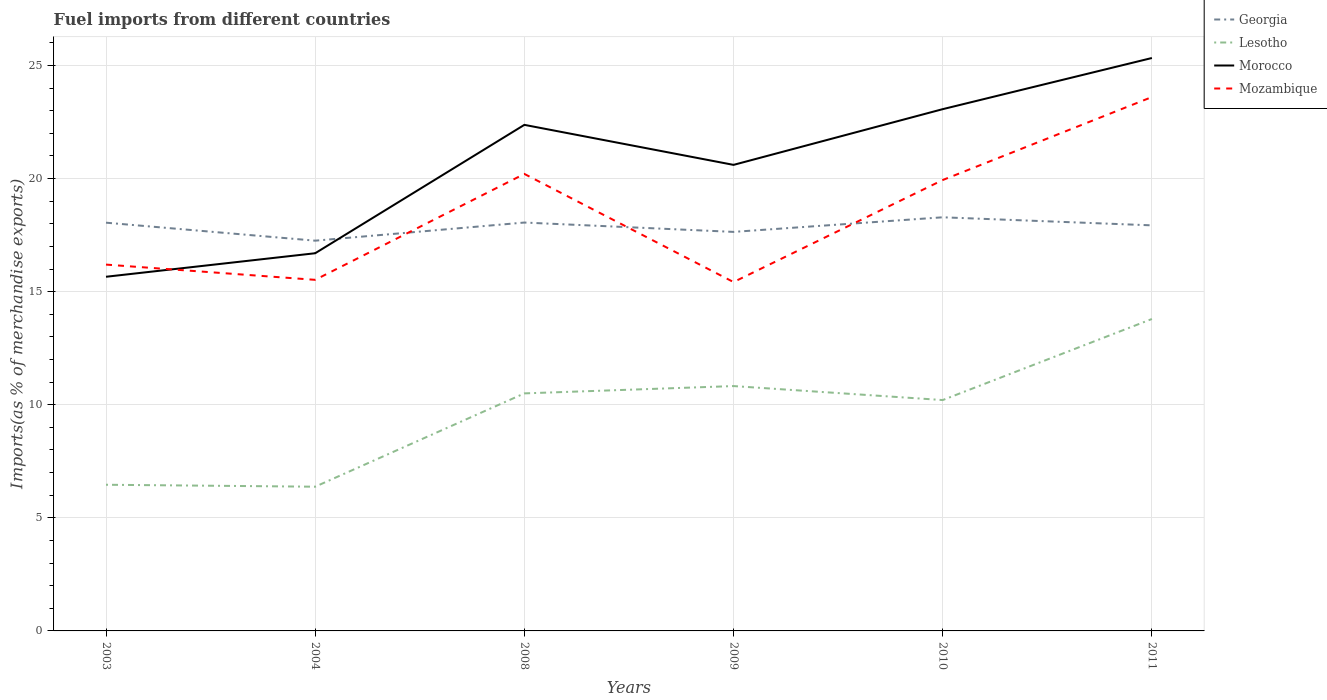Does the line corresponding to Morocco intersect with the line corresponding to Mozambique?
Keep it short and to the point. Yes. Is the number of lines equal to the number of legend labels?
Your answer should be compact. Yes. Across all years, what is the maximum percentage of imports to different countries in Georgia?
Make the answer very short. 17.25. What is the total percentage of imports to different countries in Mozambique in the graph?
Your response must be concise. 4.78. What is the difference between the highest and the second highest percentage of imports to different countries in Mozambique?
Keep it short and to the point. 8.18. What is the difference between the highest and the lowest percentage of imports to different countries in Mozambique?
Offer a terse response. 3. Is the percentage of imports to different countries in Mozambique strictly greater than the percentage of imports to different countries in Lesotho over the years?
Your response must be concise. No. What is the difference between two consecutive major ticks on the Y-axis?
Offer a very short reply. 5. Does the graph contain any zero values?
Keep it short and to the point. No. Does the graph contain grids?
Keep it short and to the point. Yes. How many legend labels are there?
Your response must be concise. 4. What is the title of the graph?
Provide a short and direct response. Fuel imports from different countries. Does "Mali" appear as one of the legend labels in the graph?
Give a very brief answer. No. What is the label or title of the X-axis?
Make the answer very short. Years. What is the label or title of the Y-axis?
Provide a short and direct response. Imports(as % of merchandise exports). What is the Imports(as % of merchandise exports) in Georgia in 2003?
Your answer should be compact. 18.05. What is the Imports(as % of merchandise exports) of Lesotho in 2003?
Offer a very short reply. 6.46. What is the Imports(as % of merchandise exports) in Morocco in 2003?
Your answer should be compact. 15.66. What is the Imports(as % of merchandise exports) of Mozambique in 2003?
Keep it short and to the point. 16.2. What is the Imports(as % of merchandise exports) of Georgia in 2004?
Ensure brevity in your answer.  17.25. What is the Imports(as % of merchandise exports) in Lesotho in 2004?
Your answer should be very brief. 6.38. What is the Imports(as % of merchandise exports) in Morocco in 2004?
Your answer should be compact. 16.7. What is the Imports(as % of merchandise exports) of Mozambique in 2004?
Your answer should be very brief. 15.52. What is the Imports(as % of merchandise exports) in Georgia in 2008?
Your response must be concise. 18.06. What is the Imports(as % of merchandise exports) of Lesotho in 2008?
Your response must be concise. 10.5. What is the Imports(as % of merchandise exports) of Morocco in 2008?
Give a very brief answer. 22.37. What is the Imports(as % of merchandise exports) in Mozambique in 2008?
Offer a terse response. 20.2. What is the Imports(as % of merchandise exports) in Georgia in 2009?
Offer a terse response. 17.64. What is the Imports(as % of merchandise exports) of Lesotho in 2009?
Give a very brief answer. 10.83. What is the Imports(as % of merchandise exports) in Morocco in 2009?
Your answer should be very brief. 20.61. What is the Imports(as % of merchandise exports) in Mozambique in 2009?
Keep it short and to the point. 15.42. What is the Imports(as % of merchandise exports) in Georgia in 2010?
Provide a succinct answer. 18.29. What is the Imports(as % of merchandise exports) in Lesotho in 2010?
Give a very brief answer. 10.21. What is the Imports(as % of merchandise exports) in Morocco in 2010?
Your answer should be compact. 23.07. What is the Imports(as % of merchandise exports) in Mozambique in 2010?
Provide a succinct answer. 19.94. What is the Imports(as % of merchandise exports) in Georgia in 2011?
Your answer should be very brief. 17.93. What is the Imports(as % of merchandise exports) of Lesotho in 2011?
Offer a very short reply. 13.79. What is the Imports(as % of merchandise exports) in Morocco in 2011?
Provide a short and direct response. 25.33. What is the Imports(as % of merchandise exports) of Mozambique in 2011?
Ensure brevity in your answer.  23.6. Across all years, what is the maximum Imports(as % of merchandise exports) of Georgia?
Your answer should be very brief. 18.29. Across all years, what is the maximum Imports(as % of merchandise exports) in Lesotho?
Your answer should be very brief. 13.79. Across all years, what is the maximum Imports(as % of merchandise exports) in Morocco?
Offer a terse response. 25.33. Across all years, what is the maximum Imports(as % of merchandise exports) in Mozambique?
Your answer should be very brief. 23.6. Across all years, what is the minimum Imports(as % of merchandise exports) in Georgia?
Offer a terse response. 17.25. Across all years, what is the minimum Imports(as % of merchandise exports) of Lesotho?
Ensure brevity in your answer.  6.38. Across all years, what is the minimum Imports(as % of merchandise exports) of Morocco?
Ensure brevity in your answer.  15.66. Across all years, what is the minimum Imports(as % of merchandise exports) in Mozambique?
Give a very brief answer. 15.42. What is the total Imports(as % of merchandise exports) in Georgia in the graph?
Give a very brief answer. 107.22. What is the total Imports(as % of merchandise exports) in Lesotho in the graph?
Make the answer very short. 58.16. What is the total Imports(as % of merchandise exports) of Morocco in the graph?
Ensure brevity in your answer.  123.74. What is the total Imports(as % of merchandise exports) in Mozambique in the graph?
Your response must be concise. 110.89. What is the difference between the Imports(as % of merchandise exports) in Georgia in 2003 and that in 2004?
Give a very brief answer. 0.8. What is the difference between the Imports(as % of merchandise exports) in Lesotho in 2003 and that in 2004?
Provide a short and direct response. 0.09. What is the difference between the Imports(as % of merchandise exports) in Morocco in 2003 and that in 2004?
Make the answer very short. -1.04. What is the difference between the Imports(as % of merchandise exports) of Mozambique in 2003 and that in 2004?
Your answer should be very brief. 0.67. What is the difference between the Imports(as % of merchandise exports) of Georgia in 2003 and that in 2008?
Keep it short and to the point. -0.01. What is the difference between the Imports(as % of merchandise exports) of Lesotho in 2003 and that in 2008?
Give a very brief answer. -4.04. What is the difference between the Imports(as % of merchandise exports) of Morocco in 2003 and that in 2008?
Offer a very short reply. -6.72. What is the difference between the Imports(as % of merchandise exports) in Mozambique in 2003 and that in 2008?
Make the answer very short. -4.01. What is the difference between the Imports(as % of merchandise exports) of Georgia in 2003 and that in 2009?
Provide a succinct answer. 0.41. What is the difference between the Imports(as % of merchandise exports) in Lesotho in 2003 and that in 2009?
Your answer should be very brief. -4.36. What is the difference between the Imports(as % of merchandise exports) of Morocco in 2003 and that in 2009?
Provide a short and direct response. -4.95. What is the difference between the Imports(as % of merchandise exports) in Mozambique in 2003 and that in 2009?
Provide a succinct answer. 0.77. What is the difference between the Imports(as % of merchandise exports) of Georgia in 2003 and that in 2010?
Keep it short and to the point. -0.24. What is the difference between the Imports(as % of merchandise exports) in Lesotho in 2003 and that in 2010?
Keep it short and to the point. -3.74. What is the difference between the Imports(as % of merchandise exports) in Morocco in 2003 and that in 2010?
Give a very brief answer. -7.41. What is the difference between the Imports(as % of merchandise exports) of Mozambique in 2003 and that in 2010?
Make the answer very short. -3.74. What is the difference between the Imports(as % of merchandise exports) in Georgia in 2003 and that in 2011?
Ensure brevity in your answer.  0.12. What is the difference between the Imports(as % of merchandise exports) in Lesotho in 2003 and that in 2011?
Offer a terse response. -7.33. What is the difference between the Imports(as % of merchandise exports) of Morocco in 2003 and that in 2011?
Ensure brevity in your answer.  -9.67. What is the difference between the Imports(as % of merchandise exports) of Mozambique in 2003 and that in 2011?
Provide a succinct answer. -7.41. What is the difference between the Imports(as % of merchandise exports) of Georgia in 2004 and that in 2008?
Provide a short and direct response. -0.8. What is the difference between the Imports(as % of merchandise exports) in Lesotho in 2004 and that in 2008?
Provide a short and direct response. -4.13. What is the difference between the Imports(as % of merchandise exports) in Morocco in 2004 and that in 2008?
Your answer should be very brief. -5.68. What is the difference between the Imports(as % of merchandise exports) of Mozambique in 2004 and that in 2008?
Offer a very short reply. -4.68. What is the difference between the Imports(as % of merchandise exports) in Georgia in 2004 and that in 2009?
Provide a short and direct response. -0.39. What is the difference between the Imports(as % of merchandise exports) in Lesotho in 2004 and that in 2009?
Keep it short and to the point. -4.45. What is the difference between the Imports(as % of merchandise exports) in Morocco in 2004 and that in 2009?
Offer a terse response. -3.91. What is the difference between the Imports(as % of merchandise exports) in Mozambique in 2004 and that in 2009?
Offer a very short reply. 0.1. What is the difference between the Imports(as % of merchandise exports) of Georgia in 2004 and that in 2010?
Provide a short and direct response. -1.03. What is the difference between the Imports(as % of merchandise exports) of Lesotho in 2004 and that in 2010?
Keep it short and to the point. -3.83. What is the difference between the Imports(as % of merchandise exports) in Morocco in 2004 and that in 2010?
Your answer should be very brief. -6.37. What is the difference between the Imports(as % of merchandise exports) in Mozambique in 2004 and that in 2010?
Give a very brief answer. -4.41. What is the difference between the Imports(as % of merchandise exports) in Georgia in 2004 and that in 2011?
Make the answer very short. -0.68. What is the difference between the Imports(as % of merchandise exports) in Lesotho in 2004 and that in 2011?
Provide a succinct answer. -7.41. What is the difference between the Imports(as % of merchandise exports) in Morocco in 2004 and that in 2011?
Offer a very short reply. -8.63. What is the difference between the Imports(as % of merchandise exports) of Mozambique in 2004 and that in 2011?
Keep it short and to the point. -8.08. What is the difference between the Imports(as % of merchandise exports) in Georgia in 2008 and that in 2009?
Ensure brevity in your answer.  0.41. What is the difference between the Imports(as % of merchandise exports) in Lesotho in 2008 and that in 2009?
Your answer should be very brief. -0.32. What is the difference between the Imports(as % of merchandise exports) in Morocco in 2008 and that in 2009?
Your answer should be compact. 1.77. What is the difference between the Imports(as % of merchandise exports) of Mozambique in 2008 and that in 2009?
Make the answer very short. 4.78. What is the difference between the Imports(as % of merchandise exports) of Georgia in 2008 and that in 2010?
Keep it short and to the point. -0.23. What is the difference between the Imports(as % of merchandise exports) in Lesotho in 2008 and that in 2010?
Keep it short and to the point. 0.29. What is the difference between the Imports(as % of merchandise exports) of Morocco in 2008 and that in 2010?
Your answer should be compact. -0.69. What is the difference between the Imports(as % of merchandise exports) in Mozambique in 2008 and that in 2010?
Offer a very short reply. 0.27. What is the difference between the Imports(as % of merchandise exports) of Georgia in 2008 and that in 2011?
Your answer should be very brief. 0.12. What is the difference between the Imports(as % of merchandise exports) in Lesotho in 2008 and that in 2011?
Offer a very short reply. -3.29. What is the difference between the Imports(as % of merchandise exports) of Morocco in 2008 and that in 2011?
Offer a terse response. -2.96. What is the difference between the Imports(as % of merchandise exports) in Mozambique in 2008 and that in 2011?
Your response must be concise. -3.4. What is the difference between the Imports(as % of merchandise exports) of Georgia in 2009 and that in 2010?
Ensure brevity in your answer.  -0.65. What is the difference between the Imports(as % of merchandise exports) of Lesotho in 2009 and that in 2010?
Keep it short and to the point. 0.62. What is the difference between the Imports(as % of merchandise exports) of Morocco in 2009 and that in 2010?
Provide a succinct answer. -2.46. What is the difference between the Imports(as % of merchandise exports) of Mozambique in 2009 and that in 2010?
Offer a very short reply. -4.51. What is the difference between the Imports(as % of merchandise exports) in Georgia in 2009 and that in 2011?
Your response must be concise. -0.29. What is the difference between the Imports(as % of merchandise exports) of Lesotho in 2009 and that in 2011?
Ensure brevity in your answer.  -2.97. What is the difference between the Imports(as % of merchandise exports) of Morocco in 2009 and that in 2011?
Provide a short and direct response. -4.72. What is the difference between the Imports(as % of merchandise exports) of Mozambique in 2009 and that in 2011?
Provide a short and direct response. -8.18. What is the difference between the Imports(as % of merchandise exports) of Georgia in 2010 and that in 2011?
Offer a terse response. 0.36. What is the difference between the Imports(as % of merchandise exports) of Lesotho in 2010 and that in 2011?
Provide a short and direct response. -3.58. What is the difference between the Imports(as % of merchandise exports) in Morocco in 2010 and that in 2011?
Provide a succinct answer. -2.26. What is the difference between the Imports(as % of merchandise exports) of Mozambique in 2010 and that in 2011?
Give a very brief answer. -3.67. What is the difference between the Imports(as % of merchandise exports) in Georgia in 2003 and the Imports(as % of merchandise exports) in Lesotho in 2004?
Make the answer very short. 11.67. What is the difference between the Imports(as % of merchandise exports) of Georgia in 2003 and the Imports(as % of merchandise exports) of Morocco in 2004?
Your answer should be very brief. 1.35. What is the difference between the Imports(as % of merchandise exports) of Georgia in 2003 and the Imports(as % of merchandise exports) of Mozambique in 2004?
Make the answer very short. 2.53. What is the difference between the Imports(as % of merchandise exports) of Lesotho in 2003 and the Imports(as % of merchandise exports) of Morocco in 2004?
Provide a succinct answer. -10.24. What is the difference between the Imports(as % of merchandise exports) of Lesotho in 2003 and the Imports(as % of merchandise exports) of Mozambique in 2004?
Your answer should be very brief. -9.06. What is the difference between the Imports(as % of merchandise exports) in Morocco in 2003 and the Imports(as % of merchandise exports) in Mozambique in 2004?
Keep it short and to the point. 0.14. What is the difference between the Imports(as % of merchandise exports) in Georgia in 2003 and the Imports(as % of merchandise exports) in Lesotho in 2008?
Offer a very short reply. 7.55. What is the difference between the Imports(as % of merchandise exports) in Georgia in 2003 and the Imports(as % of merchandise exports) in Morocco in 2008?
Ensure brevity in your answer.  -4.33. What is the difference between the Imports(as % of merchandise exports) in Georgia in 2003 and the Imports(as % of merchandise exports) in Mozambique in 2008?
Give a very brief answer. -2.16. What is the difference between the Imports(as % of merchandise exports) of Lesotho in 2003 and the Imports(as % of merchandise exports) of Morocco in 2008?
Offer a terse response. -15.91. What is the difference between the Imports(as % of merchandise exports) of Lesotho in 2003 and the Imports(as % of merchandise exports) of Mozambique in 2008?
Give a very brief answer. -13.74. What is the difference between the Imports(as % of merchandise exports) in Morocco in 2003 and the Imports(as % of merchandise exports) in Mozambique in 2008?
Make the answer very short. -4.55. What is the difference between the Imports(as % of merchandise exports) in Georgia in 2003 and the Imports(as % of merchandise exports) in Lesotho in 2009?
Offer a very short reply. 7.22. What is the difference between the Imports(as % of merchandise exports) in Georgia in 2003 and the Imports(as % of merchandise exports) in Morocco in 2009?
Provide a succinct answer. -2.56. What is the difference between the Imports(as % of merchandise exports) in Georgia in 2003 and the Imports(as % of merchandise exports) in Mozambique in 2009?
Make the answer very short. 2.63. What is the difference between the Imports(as % of merchandise exports) of Lesotho in 2003 and the Imports(as % of merchandise exports) of Morocco in 2009?
Your answer should be very brief. -14.14. What is the difference between the Imports(as % of merchandise exports) in Lesotho in 2003 and the Imports(as % of merchandise exports) in Mozambique in 2009?
Give a very brief answer. -8.96. What is the difference between the Imports(as % of merchandise exports) in Morocco in 2003 and the Imports(as % of merchandise exports) in Mozambique in 2009?
Offer a very short reply. 0.23. What is the difference between the Imports(as % of merchandise exports) in Georgia in 2003 and the Imports(as % of merchandise exports) in Lesotho in 2010?
Your answer should be compact. 7.84. What is the difference between the Imports(as % of merchandise exports) in Georgia in 2003 and the Imports(as % of merchandise exports) in Morocco in 2010?
Provide a short and direct response. -5.02. What is the difference between the Imports(as % of merchandise exports) of Georgia in 2003 and the Imports(as % of merchandise exports) of Mozambique in 2010?
Your response must be concise. -1.89. What is the difference between the Imports(as % of merchandise exports) in Lesotho in 2003 and the Imports(as % of merchandise exports) in Morocco in 2010?
Make the answer very short. -16.61. What is the difference between the Imports(as % of merchandise exports) of Lesotho in 2003 and the Imports(as % of merchandise exports) of Mozambique in 2010?
Offer a very short reply. -13.47. What is the difference between the Imports(as % of merchandise exports) in Morocco in 2003 and the Imports(as % of merchandise exports) in Mozambique in 2010?
Keep it short and to the point. -4.28. What is the difference between the Imports(as % of merchandise exports) of Georgia in 2003 and the Imports(as % of merchandise exports) of Lesotho in 2011?
Make the answer very short. 4.26. What is the difference between the Imports(as % of merchandise exports) in Georgia in 2003 and the Imports(as % of merchandise exports) in Morocco in 2011?
Offer a terse response. -7.28. What is the difference between the Imports(as % of merchandise exports) of Georgia in 2003 and the Imports(as % of merchandise exports) of Mozambique in 2011?
Keep it short and to the point. -5.55. What is the difference between the Imports(as % of merchandise exports) in Lesotho in 2003 and the Imports(as % of merchandise exports) in Morocco in 2011?
Provide a short and direct response. -18.87. What is the difference between the Imports(as % of merchandise exports) in Lesotho in 2003 and the Imports(as % of merchandise exports) in Mozambique in 2011?
Provide a succinct answer. -17.14. What is the difference between the Imports(as % of merchandise exports) of Morocco in 2003 and the Imports(as % of merchandise exports) of Mozambique in 2011?
Offer a terse response. -7.95. What is the difference between the Imports(as % of merchandise exports) in Georgia in 2004 and the Imports(as % of merchandise exports) in Lesotho in 2008?
Offer a terse response. 6.75. What is the difference between the Imports(as % of merchandise exports) in Georgia in 2004 and the Imports(as % of merchandise exports) in Morocco in 2008?
Your response must be concise. -5.12. What is the difference between the Imports(as % of merchandise exports) of Georgia in 2004 and the Imports(as % of merchandise exports) of Mozambique in 2008?
Your answer should be compact. -2.95. What is the difference between the Imports(as % of merchandise exports) in Lesotho in 2004 and the Imports(as % of merchandise exports) in Morocco in 2008?
Make the answer very short. -16. What is the difference between the Imports(as % of merchandise exports) in Lesotho in 2004 and the Imports(as % of merchandise exports) in Mozambique in 2008?
Make the answer very short. -13.83. What is the difference between the Imports(as % of merchandise exports) of Morocco in 2004 and the Imports(as % of merchandise exports) of Mozambique in 2008?
Give a very brief answer. -3.51. What is the difference between the Imports(as % of merchandise exports) in Georgia in 2004 and the Imports(as % of merchandise exports) in Lesotho in 2009?
Offer a terse response. 6.43. What is the difference between the Imports(as % of merchandise exports) in Georgia in 2004 and the Imports(as % of merchandise exports) in Morocco in 2009?
Your answer should be compact. -3.35. What is the difference between the Imports(as % of merchandise exports) of Georgia in 2004 and the Imports(as % of merchandise exports) of Mozambique in 2009?
Keep it short and to the point. 1.83. What is the difference between the Imports(as % of merchandise exports) of Lesotho in 2004 and the Imports(as % of merchandise exports) of Morocco in 2009?
Keep it short and to the point. -14.23. What is the difference between the Imports(as % of merchandise exports) in Lesotho in 2004 and the Imports(as % of merchandise exports) in Mozambique in 2009?
Keep it short and to the point. -9.05. What is the difference between the Imports(as % of merchandise exports) of Morocco in 2004 and the Imports(as % of merchandise exports) of Mozambique in 2009?
Your answer should be compact. 1.27. What is the difference between the Imports(as % of merchandise exports) of Georgia in 2004 and the Imports(as % of merchandise exports) of Lesotho in 2010?
Give a very brief answer. 7.05. What is the difference between the Imports(as % of merchandise exports) of Georgia in 2004 and the Imports(as % of merchandise exports) of Morocco in 2010?
Your response must be concise. -5.81. What is the difference between the Imports(as % of merchandise exports) of Georgia in 2004 and the Imports(as % of merchandise exports) of Mozambique in 2010?
Your answer should be very brief. -2.68. What is the difference between the Imports(as % of merchandise exports) of Lesotho in 2004 and the Imports(as % of merchandise exports) of Morocco in 2010?
Provide a short and direct response. -16.69. What is the difference between the Imports(as % of merchandise exports) of Lesotho in 2004 and the Imports(as % of merchandise exports) of Mozambique in 2010?
Offer a very short reply. -13.56. What is the difference between the Imports(as % of merchandise exports) in Morocco in 2004 and the Imports(as % of merchandise exports) in Mozambique in 2010?
Keep it short and to the point. -3.24. What is the difference between the Imports(as % of merchandise exports) of Georgia in 2004 and the Imports(as % of merchandise exports) of Lesotho in 2011?
Your answer should be compact. 3.46. What is the difference between the Imports(as % of merchandise exports) in Georgia in 2004 and the Imports(as % of merchandise exports) in Morocco in 2011?
Offer a terse response. -8.08. What is the difference between the Imports(as % of merchandise exports) in Georgia in 2004 and the Imports(as % of merchandise exports) in Mozambique in 2011?
Ensure brevity in your answer.  -6.35. What is the difference between the Imports(as % of merchandise exports) of Lesotho in 2004 and the Imports(as % of merchandise exports) of Morocco in 2011?
Offer a very short reply. -18.95. What is the difference between the Imports(as % of merchandise exports) in Lesotho in 2004 and the Imports(as % of merchandise exports) in Mozambique in 2011?
Make the answer very short. -17.23. What is the difference between the Imports(as % of merchandise exports) of Morocco in 2004 and the Imports(as % of merchandise exports) of Mozambique in 2011?
Offer a very short reply. -6.91. What is the difference between the Imports(as % of merchandise exports) of Georgia in 2008 and the Imports(as % of merchandise exports) of Lesotho in 2009?
Ensure brevity in your answer.  7.23. What is the difference between the Imports(as % of merchandise exports) of Georgia in 2008 and the Imports(as % of merchandise exports) of Morocco in 2009?
Provide a short and direct response. -2.55. What is the difference between the Imports(as % of merchandise exports) of Georgia in 2008 and the Imports(as % of merchandise exports) of Mozambique in 2009?
Your response must be concise. 2.63. What is the difference between the Imports(as % of merchandise exports) of Lesotho in 2008 and the Imports(as % of merchandise exports) of Morocco in 2009?
Give a very brief answer. -10.1. What is the difference between the Imports(as % of merchandise exports) in Lesotho in 2008 and the Imports(as % of merchandise exports) in Mozambique in 2009?
Your answer should be compact. -4.92. What is the difference between the Imports(as % of merchandise exports) in Morocco in 2008 and the Imports(as % of merchandise exports) in Mozambique in 2009?
Provide a succinct answer. 6.95. What is the difference between the Imports(as % of merchandise exports) of Georgia in 2008 and the Imports(as % of merchandise exports) of Lesotho in 2010?
Your response must be concise. 7.85. What is the difference between the Imports(as % of merchandise exports) of Georgia in 2008 and the Imports(as % of merchandise exports) of Morocco in 2010?
Your answer should be compact. -5.01. What is the difference between the Imports(as % of merchandise exports) of Georgia in 2008 and the Imports(as % of merchandise exports) of Mozambique in 2010?
Provide a short and direct response. -1.88. What is the difference between the Imports(as % of merchandise exports) in Lesotho in 2008 and the Imports(as % of merchandise exports) in Morocco in 2010?
Provide a short and direct response. -12.57. What is the difference between the Imports(as % of merchandise exports) of Lesotho in 2008 and the Imports(as % of merchandise exports) of Mozambique in 2010?
Offer a terse response. -9.43. What is the difference between the Imports(as % of merchandise exports) in Morocco in 2008 and the Imports(as % of merchandise exports) in Mozambique in 2010?
Your response must be concise. 2.44. What is the difference between the Imports(as % of merchandise exports) of Georgia in 2008 and the Imports(as % of merchandise exports) of Lesotho in 2011?
Give a very brief answer. 4.26. What is the difference between the Imports(as % of merchandise exports) in Georgia in 2008 and the Imports(as % of merchandise exports) in Morocco in 2011?
Give a very brief answer. -7.27. What is the difference between the Imports(as % of merchandise exports) of Georgia in 2008 and the Imports(as % of merchandise exports) of Mozambique in 2011?
Keep it short and to the point. -5.55. What is the difference between the Imports(as % of merchandise exports) in Lesotho in 2008 and the Imports(as % of merchandise exports) in Morocco in 2011?
Offer a terse response. -14.83. What is the difference between the Imports(as % of merchandise exports) in Lesotho in 2008 and the Imports(as % of merchandise exports) in Mozambique in 2011?
Keep it short and to the point. -13.1. What is the difference between the Imports(as % of merchandise exports) of Morocco in 2008 and the Imports(as % of merchandise exports) of Mozambique in 2011?
Make the answer very short. -1.23. What is the difference between the Imports(as % of merchandise exports) of Georgia in 2009 and the Imports(as % of merchandise exports) of Lesotho in 2010?
Make the answer very short. 7.43. What is the difference between the Imports(as % of merchandise exports) of Georgia in 2009 and the Imports(as % of merchandise exports) of Morocco in 2010?
Keep it short and to the point. -5.43. What is the difference between the Imports(as % of merchandise exports) in Georgia in 2009 and the Imports(as % of merchandise exports) in Mozambique in 2010?
Your response must be concise. -2.29. What is the difference between the Imports(as % of merchandise exports) of Lesotho in 2009 and the Imports(as % of merchandise exports) of Morocco in 2010?
Your response must be concise. -12.24. What is the difference between the Imports(as % of merchandise exports) of Lesotho in 2009 and the Imports(as % of merchandise exports) of Mozambique in 2010?
Offer a very short reply. -9.11. What is the difference between the Imports(as % of merchandise exports) of Morocco in 2009 and the Imports(as % of merchandise exports) of Mozambique in 2010?
Provide a succinct answer. 0.67. What is the difference between the Imports(as % of merchandise exports) of Georgia in 2009 and the Imports(as % of merchandise exports) of Lesotho in 2011?
Offer a very short reply. 3.85. What is the difference between the Imports(as % of merchandise exports) in Georgia in 2009 and the Imports(as % of merchandise exports) in Morocco in 2011?
Ensure brevity in your answer.  -7.69. What is the difference between the Imports(as % of merchandise exports) in Georgia in 2009 and the Imports(as % of merchandise exports) in Mozambique in 2011?
Your response must be concise. -5.96. What is the difference between the Imports(as % of merchandise exports) of Lesotho in 2009 and the Imports(as % of merchandise exports) of Morocco in 2011?
Provide a short and direct response. -14.5. What is the difference between the Imports(as % of merchandise exports) of Lesotho in 2009 and the Imports(as % of merchandise exports) of Mozambique in 2011?
Your answer should be very brief. -12.78. What is the difference between the Imports(as % of merchandise exports) of Morocco in 2009 and the Imports(as % of merchandise exports) of Mozambique in 2011?
Give a very brief answer. -3. What is the difference between the Imports(as % of merchandise exports) of Georgia in 2010 and the Imports(as % of merchandise exports) of Lesotho in 2011?
Offer a terse response. 4.5. What is the difference between the Imports(as % of merchandise exports) in Georgia in 2010 and the Imports(as % of merchandise exports) in Morocco in 2011?
Your answer should be very brief. -7.04. What is the difference between the Imports(as % of merchandise exports) in Georgia in 2010 and the Imports(as % of merchandise exports) in Mozambique in 2011?
Your answer should be very brief. -5.32. What is the difference between the Imports(as % of merchandise exports) of Lesotho in 2010 and the Imports(as % of merchandise exports) of Morocco in 2011?
Your answer should be very brief. -15.12. What is the difference between the Imports(as % of merchandise exports) of Lesotho in 2010 and the Imports(as % of merchandise exports) of Mozambique in 2011?
Keep it short and to the point. -13.4. What is the difference between the Imports(as % of merchandise exports) of Morocco in 2010 and the Imports(as % of merchandise exports) of Mozambique in 2011?
Offer a terse response. -0.54. What is the average Imports(as % of merchandise exports) in Georgia per year?
Provide a succinct answer. 17.87. What is the average Imports(as % of merchandise exports) of Lesotho per year?
Ensure brevity in your answer.  9.69. What is the average Imports(as % of merchandise exports) in Morocco per year?
Provide a short and direct response. 20.62. What is the average Imports(as % of merchandise exports) of Mozambique per year?
Provide a short and direct response. 18.48. In the year 2003, what is the difference between the Imports(as % of merchandise exports) of Georgia and Imports(as % of merchandise exports) of Lesotho?
Provide a short and direct response. 11.59. In the year 2003, what is the difference between the Imports(as % of merchandise exports) of Georgia and Imports(as % of merchandise exports) of Morocco?
Your response must be concise. 2.39. In the year 2003, what is the difference between the Imports(as % of merchandise exports) in Georgia and Imports(as % of merchandise exports) in Mozambique?
Provide a short and direct response. 1.85. In the year 2003, what is the difference between the Imports(as % of merchandise exports) of Lesotho and Imports(as % of merchandise exports) of Morocco?
Offer a very short reply. -9.2. In the year 2003, what is the difference between the Imports(as % of merchandise exports) of Lesotho and Imports(as % of merchandise exports) of Mozambique?
Offer a very short reply. -9.73. In the year 2003, what is the difference between the Imports(as % of merchandise exports) in Morocco and Imports(as % of merchandise exports) in Mozambique?
Give a very brief answer. -0.54. In the year 2004, what is the difference between the Imports(as % of merchandise exports) of Georgia and Imports(as % of merchandise exports) of Lesotho?
Make the answer very short. 10.88. In the year 2004, what is the difference between the Imports(as % of merchandise exports) in Georgia and Imports(as % of merchandise exports) in Morocco?
Keep it short and to the point. 0.56. In the year 2004, what is the difference between the Imports(as % of merchandise exports) in Georgia and Imports(as % of merchandise exports) in Mozambique?
Provide a succinct answer. 1.73. In the year 2004, what is the difference between the Imports(as % of merchandise exports) of Lesotho and Imports(as % of merchandise exports) of Morocco?
Your answer should be very brief. -10.32. In the year 2004, what is the difference between the Imports(as % of merchandise exports) of Lesotho and Imports(as % of merchandise exports) of Mozambique?
Provide a succinct answer. -9.15. In the year 2004, what is the difference between the Imports(as % of merchandise exports) of Morocco and Imports(as % of merchandise exports) of Mozambique?
Make the answer very short. 1.18. In the year 2008, what is the difference between the Imports(as % of merchandise exports) of Georgia and Imports(as % of merchandise exports) of Lesotho?
Offer a very short reply. 7.55. In the year 2008, what is the difference between the Imports(as % of merchandise exports) of Georgia and Imports(as % of merchandise exports) of Morocco?
Provide a short and direct response. -4.32. In the year 2008, what is the difference between the Imports(as % of merchandise exports) in Georgia and Imports(as % of merchandise exports) in Mozambique?
Make the answer very short. -2.15. In the year 2008, what is the difference between the Imports(as % of merchandise exports) in Lesotho and Imports(as % of merchandise exports) in Morocco?
Ensure brevity in your answer.  -11.87. In the year 2008, what is the difference between the Imports(as % of merchandise exports) of Lesotho and Imports(as % of merchandise exports) of Mozambique?
Your answer should be compact. -9.7. In the year 2008, what is the difference between the Imports(as % of merchandise exports) in Morocco and Imports(as % of merchandise exports) in Mozambique?
Your answer should be compact. 2.17. In the year 2009, what is the difference between the Imports(as % of merchandise exports) of Georgia and Imports(as % of merchandise exports) of Lesotho?
Provide a short and direct response. 6.82. In the year 2009, what is the difference between the Imports(as % of merchandise exports) in Georgia and Imports(as % of merchandise exports) in Morocco?
Your response must be concise. -2.96. In the year 2009, what is the difference between the Imports(as % of merchandise exports) of Georgia and Imports(as % of merchandise exports) of Mozambique?
Your response must be concise. 2.22. In the year 2009, what is the difference between the Imports(as % of merchandise exports) in Lesotho and Imports(as % of merchandise exports) in Morocco?
Offer a terse response. -9.78. In the year 2009, what is the difference between the Imports(as % of merchandise exports) in Lesotho and Imports(as % of merchandise exports) in Mozambique?
Make the answer very short. -4.6. In the year 2009, what is the difference between the Imports(as % of merchandise exports) in Morocco and Imports(as % of merchandise exports) in Mozambique?
Provide a succinct answer. 5.18. In the year 2010, what is the difference between the Imports(as % of merchandise exports) of Georgia and Imports(as % of merchandise exports) of Lesotho?
Keep it short and to the point. 8.08. In the year 2010, what is the difference between the Imports(as % of merchandise exports) of Georgia and Imports(as % of merchandise exports) of Morocco?
Offer a very short reply. -4.78. In the year 2010, what is the difference between the Imports(as % of merchandise exports) of Georgia and Imports(as % of merchandise exports) of Mozambique?
Offer a very short reply. -1.65. In the year 2010, what is the difference between the Imports(as % of merchandise exports) in Lesotho and Imports(as % of merchandise exports) in Morocco?
Ensure brevity in your answer.  -12.86. In the year 2010, what is the difference between the Imports(as % of merchandise exports) of Lesotho and Imports(as % of merchandise exports) of Mozambique?
Give a very brief answer. -9.73. In the year 2010, what is the difference between the Imports(as % of merchandise exports) in Morocco and Imports(as % of merchandise exports) in Mozambique?
Your answer should be very brief. 3.13. In the year 2011, what is the difference between the Imports(as % of merchandise exports) of Georgia and Imports(as % of merchandise exports) of Lesotho?
Your answer should be very brief. 4.14. In the year 2011, what is the difference between the Imports(as % of merchandise exports) of Georgia and Imports(as % of merchandise exports) of Morocco?
Your response must be concise. -7.4. In the year 2011, what is the difference between the Imports(as % of merchandise exports) of Georgia and Imports(as % of merchandise exports) of Mozambique?
Give a very brief answer. -5.67. In the year 2011, what is the difference between the Imports(as % of merchandise exports) in Lesotho and Imports(as % of merchandise exports) in Morocco?
Your answer should be very brief. -11.54. In the year 2011, what is the difference between the Imports(as % of merchandise exports) in Lesotho and Imports(as % of merchandise exports) in Mozambique?
Your answer should be very brief. -9.81. In the year 2011, what is the difference between the Imports(as % of merchandise exports) in Morocco and Imports(as % of merchandise exports) in Mozambique?
Give a very brief answer. 1.73. What is the ratio of the Imports(as % of merchandise exports) in Georgia in 2003 to that in 2004?
Offer a terse response. 1.05. What is the ratio of the Imports(as % of merchandise exports) in Lesotho in 2003 to that in 2004?
Offer a very short reply. 1.01. What is the ratio of the Imports(as % of merchandise exports) of Morocco in 2003 to that in 2004?
Make the answer very short. 0.94. What is the ratio of the Imports(as % of merchandise exports) in Mozambique in 2003 to that in 2004?
Your answer should be very brief. 1.04. What is the ratio of the Imports(as % of merchandise exports) of Lesotho in 2003 to that in 2008?
Offer a terse response. 0.62. What is the ratio of the Imports(as % of merchandise exports) in Morocco in 2003 to that in 2008?
Offer a very short reply. 0.7. What is the ratio of the Imports(as % of merchandise exports) in Mozambique in 2003 to that in 2008?
Provide a short and direct response. 0.8. What is the ratio of the Imports(as % of merchandise exports) of Georgia in 2003 to that in 2009?
Provide a short and direct response. 1.02. What is the ratio of the Imports(as % of merchandise exports) of Lesotho in 2003 to that in 2009?
Your answer should be compact. 0.6. What is the ratio of the Imports(as % of merchandise exports) of Morocco in 2003 to that in 2009?
Offer a terse response. 0.76. What is the ratio of the Imports(as % of merchandise exports) of Mozambique in 2003 to that in 2009?
Provide a short and direct response. 1.05. What is the ratio of the Imports(as % of merchandise exports) in Lesotho in 2003 to that in 2010?
Offer a very short reply. 0.63. What is the ratio of the Imports(as % of merchandise exports) in Morocco in 2003 to that in 2010?
Provide a succinct answer. 0.68. What is the ratio of the Imports(as % of merchandise exports) in Mozambique in 2003 to that in 2010?
Your response must be concise. 0.81. What is the ratio of the Imports(as % of merchandise exports) in Georgia in 2003 to that in 2011?
Your answer should be compact. 1.01. What is the ratio of the Imports(as % of merchandise exports) of Lesotho in 2003 to that in 2011?
Provide a short and direct response. 0.47. What is the ratio of the Imports(as % of merchandise exports) in Morocco in 2003 to that in 2011?
Offer a terse response. 0.62. What is the ratio of the Imports(as % of merchandise exports) in Mozambique in 2003 to that in 2011?
Ensure brevity in your answer.  0.69. What is the ratio of the Imports(as % of merchandise exports) of Georgia in 2004 to that in 2008?
Your answer should be very brief. 0.96. What is the ratio of the Imports(as % of merchandise exports) in Lesotho in 2004 to that in 2008?
Give a very brief answer. 0.61. What is the ratio of the Imports(as % of merchandise exports) of Morocco in 2004 to that in 2008?
Offer a terse response. 0.75. What is the ratio of the Imports(as % of merchandise exports) in Mozambique in 2004 to that in 2008?
Ensure brevity in your answer.  0.77. What is the ratio of the Imports(as % of merchandise exports) of Lesotho in 2004 to that in 2009?
Keep it short and to the point. 0.59. What is the ratio of the Imports(as % of merchandise exports) of Morocco in 2004 to that in 2009?
Your answer should be very brief. 0.81. What is the ratio of the Imports(as % of merchandise exports) in Mozambique in 2004 to that in 2009?
Offer a terse response. 1.01. What is the ratio of the Imports(as % of merchandise exports) of Georgia in 2004 to that in 2010?
Make the answer very short. 0.94. What is the ratio of the Imports(as % of merchandise exports) of Lesotho in 2004 to that in 2010?
Offer a very short reply. 0.62. What is the ratio of the Imports(as % of merchandise exports) in Morocco in 2004 to that in 2010?
Offer a very short reply. 0.72. What is the ratio of the Imports(as % of merchandise exports) of Mozambique in 2004 to that in 2010?
Offer a very short reply. 0.78. What is the ratio of the Imports(as % of merchandise exports) of Georgia in 2004 to that in 2011?
Give a very brief answer. 0.96. What is the ratio of the Imports(as % of merchandise exports) of Lesotho in 2004 to that in 2011?
Make the answer very short. 0.46. What is the ratio of the Imports(as % of merchandise exports) in Morocco in 2004 to that in 2011?
Offer a terse response. 0.66. What is the ratio of the Imports(as % of merchandise exports) of Mozambique in 2004 to that in 2011?
Your answer should be compact. 0.66. What is the ratio of the Imports(as % of merchandise exports) in Georgia in 2008 to that in 2009?
Provide a succinct answer. 1.02. What is the ratio of the Imports(as % of merchandise exports) in Lesotho in 2008 to that in 2009?
Your response must be concise. 0.97. What is the ratio of the Imports(as % of merchandise exports) in Morocco in 2008 to that in 2009?
Keep it short and to the point. 1.09. What is the ratio of the Imports(as % of merchandise exports) in Mozambique in 2008 to that in 2009?
Offer a very short reply. 1.31. What is the ratio of the Imports(as % of merchandise exports) of Georgia in 2008 to that in 2010?
Keep it short and to the point. 0.99. What is the ratio of the Imports(as % of merchandise exports) of Lesotho in 2008 to that in 2010?
Offer a very short reply. 1.03. What is the ratio of the Imports(as % of merchandise exports) in Morocco in 2008 to that in 2010?
Provide a succinct answer. 0.97. What is the ratio of the Imports(as % of merchandise exports) in Mozambique in 2008 to that in 2010?
Provide a succinct answer. 1.01. What is the ratio of the Imports(as % of merchandise exports) in Georgia in 2008 to that in 2011?
Make the answer very short. 1.01. What is the ratio of the Imports(as % of merchandise exports) in Lesotho in 2008 to that in 2011?
Keep it short and to the point. 0.76. What is the ratio of the Imports(as % of merchandise exports) of Morocco in 2008 to that in 2011?
Offer a very short reply. 0.88. What is the ratio of the Imports(as % of merchandise exports) in Mozambique in 2008 to that in 2011?
Offer a terse response. 0.86. What is the ratio of the Imports(as % of merchandise exports) of Georgia in 2009 to that in 2010?
Your answer should be compact. 0.96. What is the ratio of the Imports(as % of merchandise exports) of Lesotho in 2009 to that in 2010?
Keep it short and to the point. 1.06. What is the ratio of the Imports(as % of merchandise exports) of Morocco in 2009 to that in 2010?
Provide a succinct answer. 0.89. What is the ratio of the Imports(as % of merchandise exports) of Mozambique in 2009 to that in 2010?
Offer a terse response. 0.77. What is the ratio of the Imports(as % of merchandise exports) in Georgia in 2009 to that in 2011?
Your answer should be very brief. 0.98. What is the ratio of the Imports(as % of merchandise exports) in Lesotho in 2009 to that in 2011?
Offer a terse response. 0.79. What is the ratio of the Imports(as % of merchandise exports) in Morocco in 2009 to that in 2011?
Provide a short and direct response. 0.81. What is the ratio of the Imports(as % of merchandise exports) of Mozambique in 2009 to that in 2011?
Your answer should be very brief. 0.65. What is the ratio of the Imports(as % of merchandise exports) in Georgia in 2010 to that in 2011?
Provide a succinct answer. 1.02. What is the ratio of the Imports(as % of merchandise exports) in Lesotho in 2010 to that in 2011?
Offer a terse response. 0.74. What is the ratio of the Imports(as % of merchandise exports) of Morocco in 2010 to that in 2011?
Provide a succinct answer. 0.91. What is the ratio of the Imports(as % of merchandise exports) in Mozambique in 2010 to that in 2011?
Provide a short and direct response. 0.84. What is the difference between the highest and the second highest Imports(as % of merchandise exports) in Georgia?
Ensure brevity in your answer.  0.23. What is the difference between the highest and the second highest Imports(as % of merchandise exports) in Lesotho?
Ensure brevity in your answer.  2.97. What is the difference between the highest and the second highest Imports(as % of merchandise exports) in Morocco?
Offer a terse response. 2.26. What is the difference between the highest and the second highest Imports(as % of merchandise exports) in Mozambique?
Offer a terse response. 3.4. What is the difference between the highest and the lowest Imports(as % of merchandise exports) of Georgia?
Make the answer very short. 1.03. What is the difference between the highest and the lowest Imports(as % of merchandise exports) in Lesotho?
Offer a terse response. 7.41. What is the difference between the highest and the lowest Imports(as % of merchandise exports) of Morocco?
Provide a succinct answer. 9.67. What is the difference between the highest and the lowest Imports(as % of merchandise exports) of Mozambique?
Ensure brevity in your answer.  8.18. 